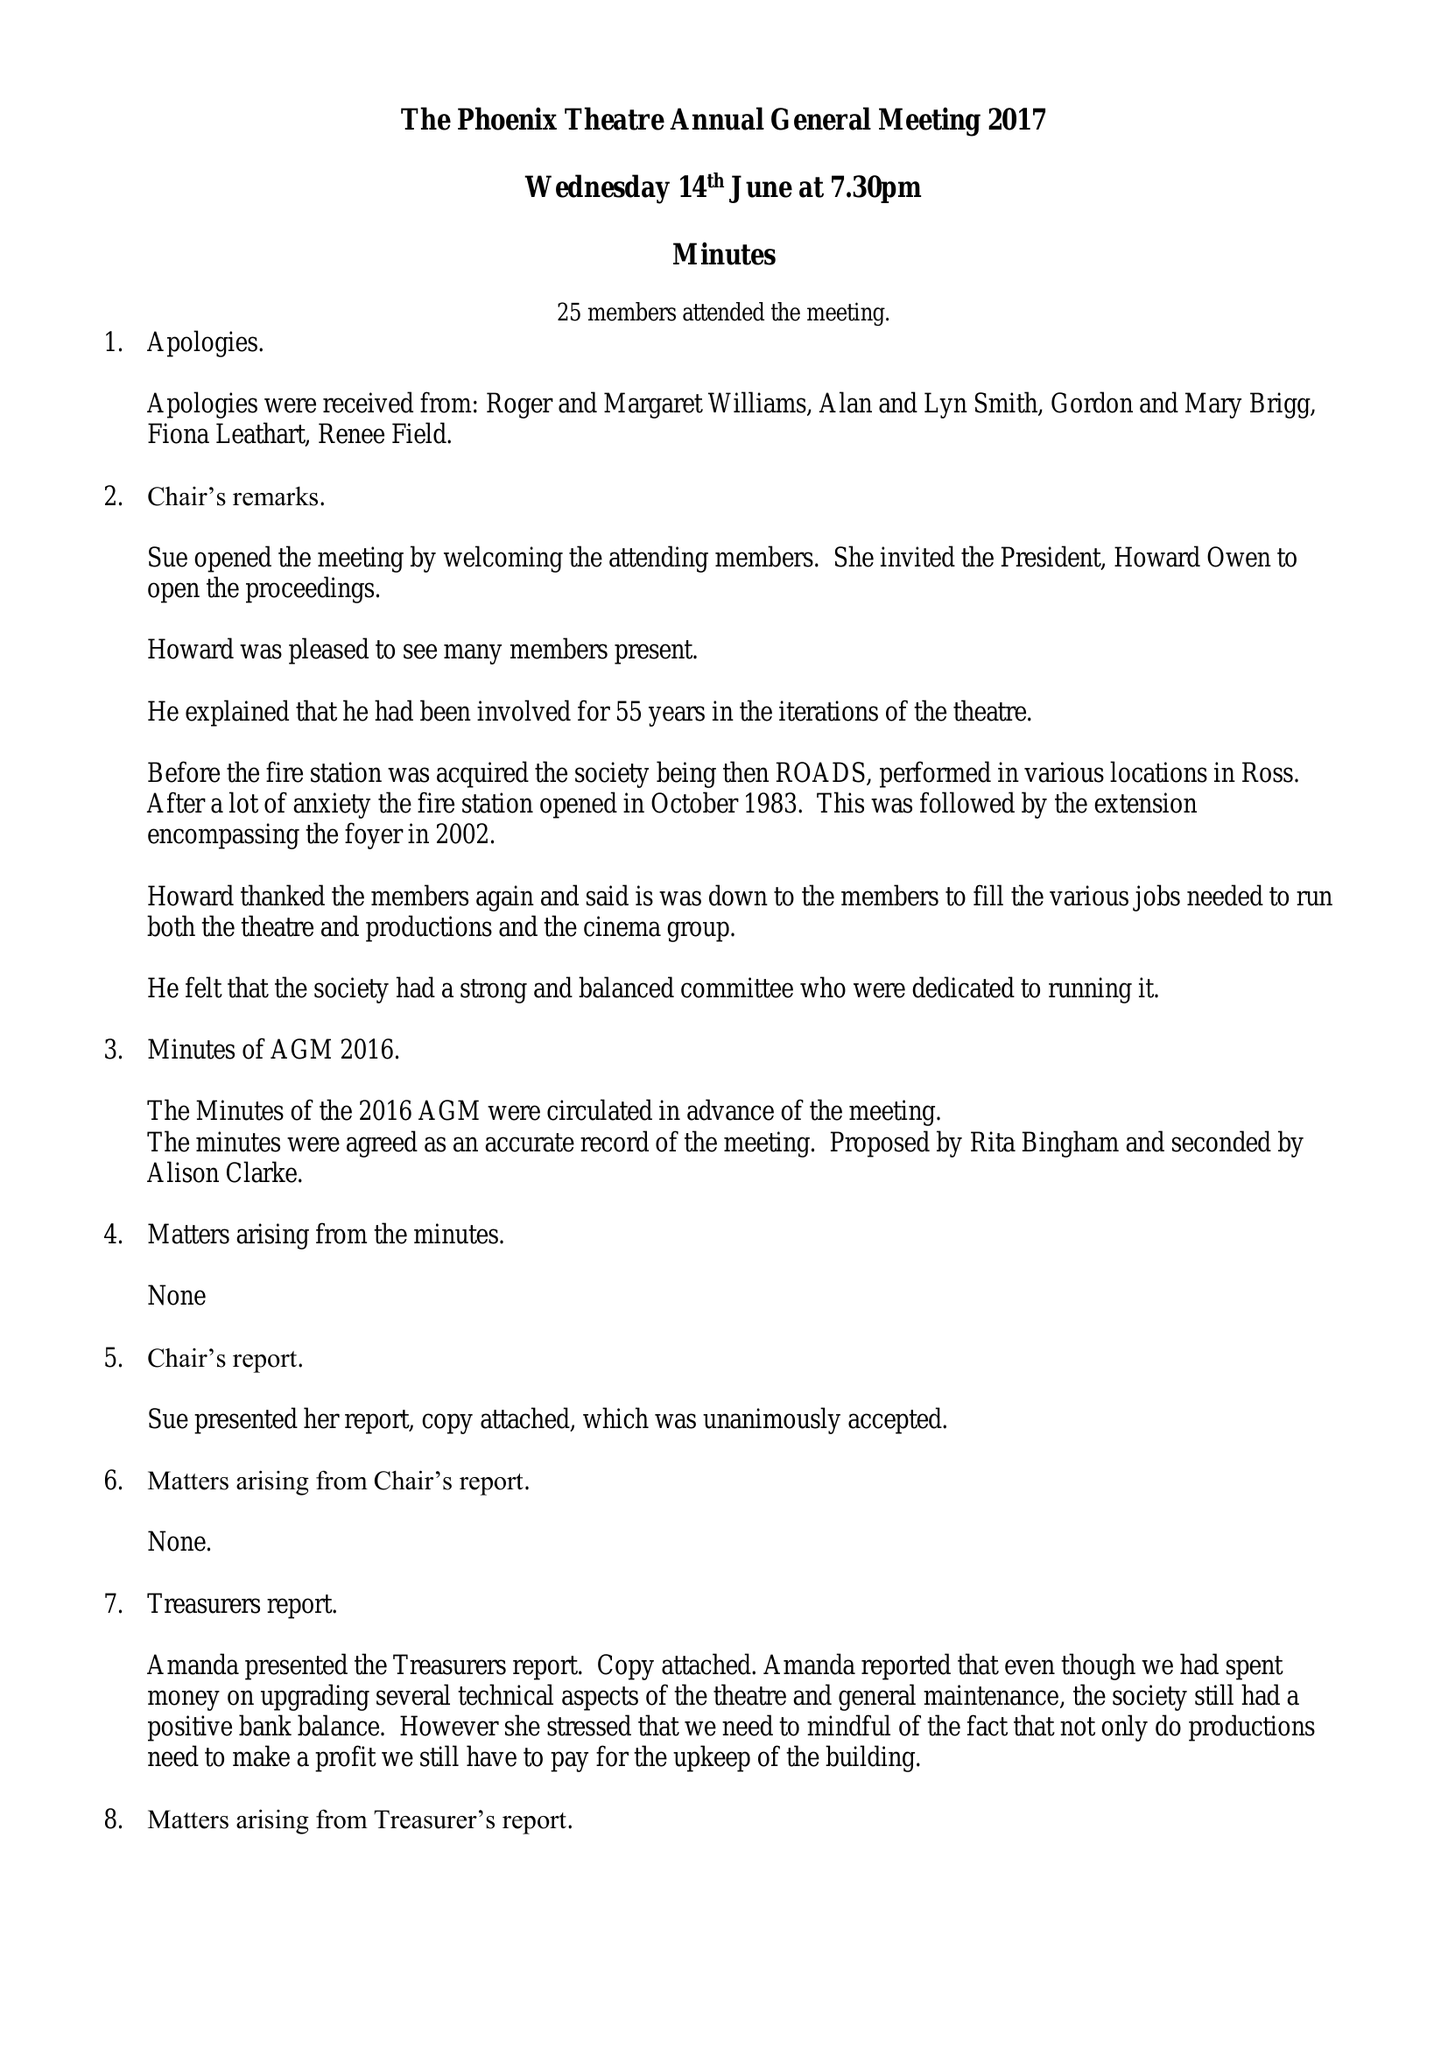What is the value for the income_annually_in_british_pounds?
Answer the question using a single word or phrase. 33487.38 